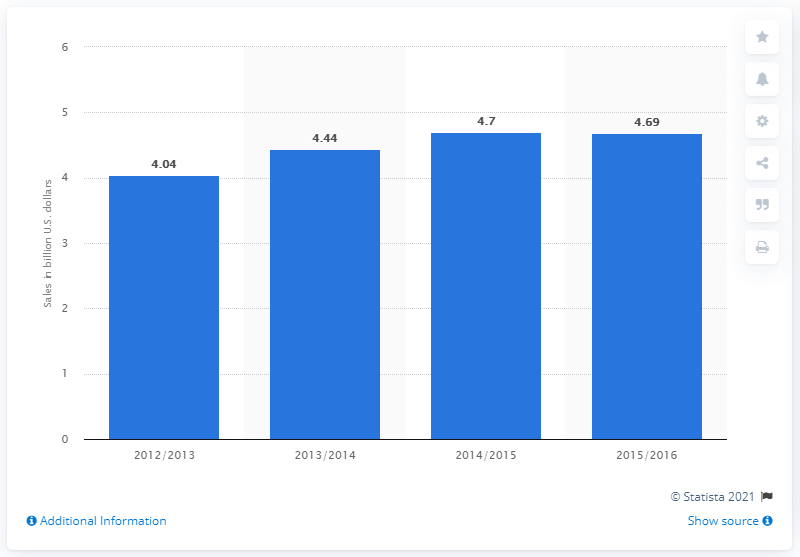Mention a couple of crucial points in this snapshot. In the 2015/2016 fiscal year, snow sports retail sales in the United States totaled approximately 4.69 billion U.S. dollars. 